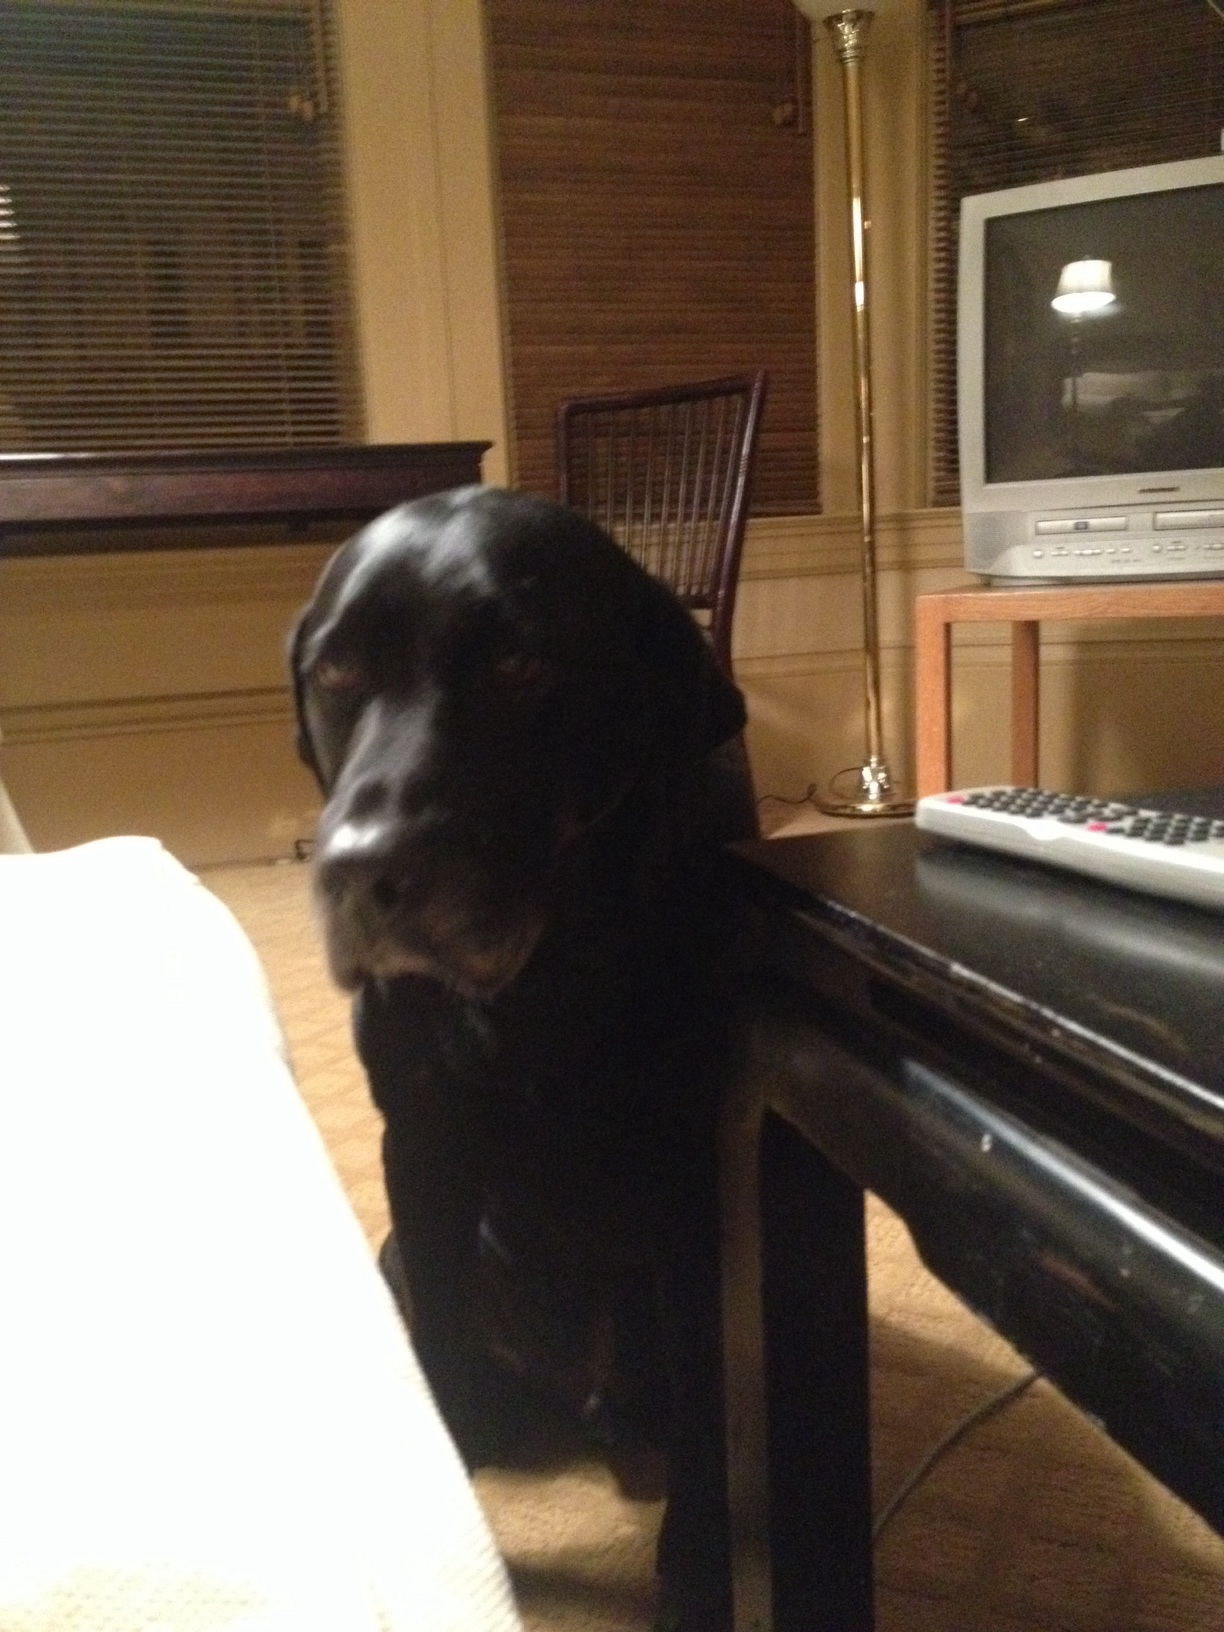Is there anything in the room that suggests the dog's personality or habits? The room features a comfortable-looking rug and a casual setting, suggesting the dog may enjoy lounging and spending time near its family. The presence of a remote control on the table might indicate that the dog also spends time in this room during family relaxation times or movie nights. 